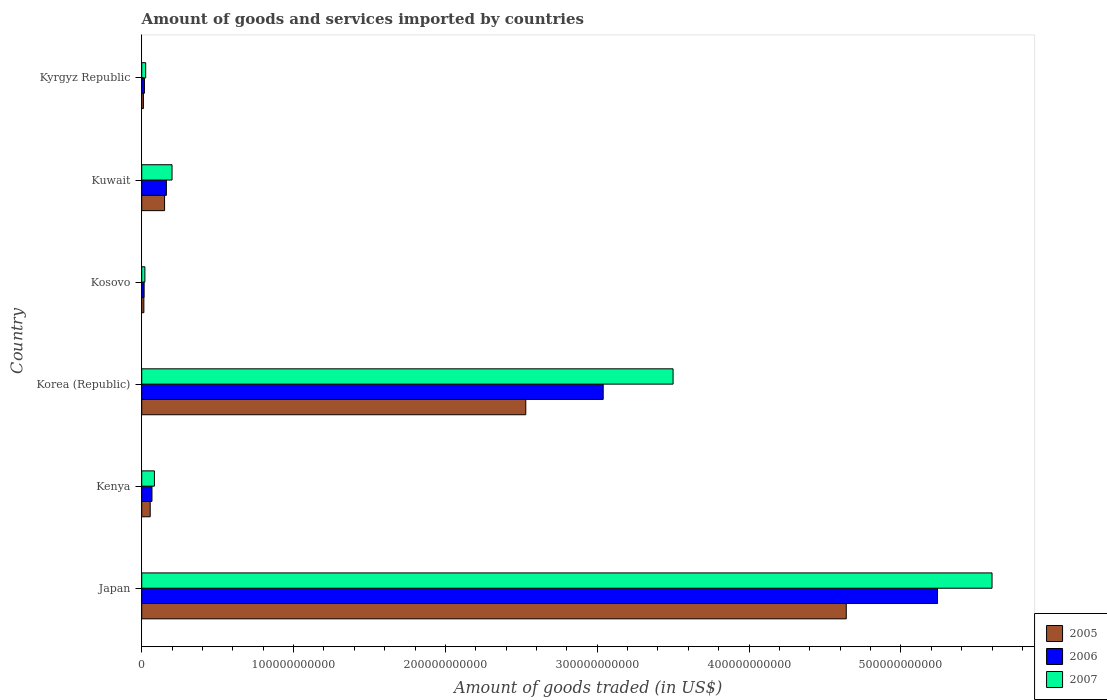How many groups of bars are there?
Your answer should be very brief. 6. Are the number of bars on each tick of the Y-axis equal?
Make the answer very short. Yes. How many bars are there on the 1st tick from the top?
Provide a succinct answer. 3. What is the label of the 5th group of bars from the top?
Give a very brief answer. Kenya. In how many cases, is the number of bars for a given country not equal to the number of legend labels?
Provide a short and direct response. 0. What is the total amount of goods and services imported in 2006 in Kosovo?
Provide a short and direct response. 1.58e+09. Across all countries, what is the maximum total amount of goods and services imported in 2005?
Provide a short and direct response. 4.64e+11. Across all countries, what is the minimum total amount of goods and services imported in 2005?
Provide a succinct answer. 1.11e+09. In which country was the total amount of goods and services imported in 2006 maximum?
Your answer should be compact. Japan. In which country was the total amount of goods and services imported in 2007 minimum?
Provide a short and direct response. Kosovo. What is the total total amount of goods and services imported in 2005 in the graph?
Keep it short and to the point. 7.40e+11. What is the difference between the total amount of goods and services imported in 2007 in Japan and that in Kuwait?
Offer a very short reply. 5.40e+11. What is the difference between the total amount of goods and services imported in 2007 in Japan and the total amount of goods and services imported in 2005 in Korea (Republic)?
Give a very brief answer. 3.07e+11. What is the average total amount of goods and services imported in 2007 per country?
Offer a very short reply. 1.57e+11. What is the difference between the total amount of goods and services imported in 2007 and total amount of goods and services imported in 2005 in Japan?
Provide a succinct answer. 9.60e+1. What is the ratio of the total amount of goods and services imported in 2006 in Japan to that in Kenya?
Offer a very short reply. 77.62. What is the difference between the highest and the second highest total amount of goods and services imported in 2005?
Ensure brevity in your answer.  2.11e+11. What is the difference between the highest and the lowest total amount of goods and services imported in 2005?
Provide a succinct answer. 4.63e+11. What does the 3rd bar from the top in Kosovo represents?
Offer a terse response. 2005. How many countries are there in the graph?
Your answer should be compact. 6. What is the difference between two consecutive major ticks on the X-axis?
Offer a very short reply. 1.00e+11. Are the values on the major ticks of X-axis written in scientific E-notation?
Offer a terse response. No. Does the graph contain any zero values?
Ensure brevity in your answer.  No. What is the title of the graph?
Ensure brevity in your answer.  Amount of goods and services imported by countries. Does "1990" appear as one of the legend labels in the graph?
Your answer should be compact. No. What is the label or title of the X-axis?
Make the answer very short. Amount of goods traded (in US$). What is the label or title of the Y-axis?
Ensure brevity in your answer.  Country. What is the Amount of goods traded (in US$) in 2005 in Japan?
Give a very brief answer. 4.64e+11. What is the Amount of goods traded (in US$) of 2006 in Japan?
Provide a succinct answer. 5.24e+11. What is the Amount of goods traded (in US$) in 2007 in Japan?
Offer a very short reply. 5.60e+11. What is the Amount of goods traded (in US$) in 2005 in Kenya?
Provide a short and direct response. 5.59e+09. What is the Amount of goods traded (in US$) of 2006 in Kenya?
Give a very brief answer. 6.75e+09. What is the Amount of goods traded (in US$) in 2007 in Kenya?
Provide a succinct answer. 8.37e+09. What is the Amount of goods traded (in US$) of 2005 in Korea (Republic)?
Offer a very short reply. 2.53e+11. What is the Amount of goods traded (in US$) of 2006 in Korea (Republic)?
Your response must be concise. 3.04e+11. What is the Amount of goods traded (in US$) of 2007 in Korea (Republic)?
Offer a very short reply. 3.50e+11. What is the Amount of goods traded (in US$) in 2005 in Kosovo?
Your answer should be compact. 1.42e+09. What is the Amount of goods traded (in US$) of 2006 in Kosovo?
Offer a very short reply. 1.58e+09. What is the Amount of goods traded (in US$) of 2007 in Kosovo?
Make the answer very short. 2.08e+09. What is the Amount of goods traded (in US$) of 2005 in Kuwait?
Provide a succinct answer. 1.51e+1. What is the Amount of goods traded (in US$) of 2006 in Kuwait?
Provide a succinct answer. 1.62e+1. What is the Amount of goods traded (in US$) of 2007 in Kuwait?
Your response must be concise. 2.00e+1. What is the Amount of goods traded (in US$) in 2005 in Kyrgyz Republic?
Provide a succinct answer. 1.11e+09. What is the Amount of goods traded (in US$) in 2006 in Kyrgyz Republic?
Your response must be concise. 1.79e+09. What is the Amount of goods traded (in US$) in 2007 in Kyrgyz Republic?
Keep it short and to the point. 2.61e+09. Across all countries, what is the maximum Amount of goods traded (in US$) in 2005?
Give a very brief answer. 4.64e+11. Across all countries, what is the maximum Amount of goods traded (in US$) in 2006?
Provide a succinct answer. 5.24e+11. Across all countries, what is the maximum Amount of goods traded (in US$) in 2007?
Provide a succinct answer. 5.60e+11. Across all countries, what is the minimum Amount of goods traded (in US$) of 2005?
Your response must be concise. 1.11e+09. Across all countries, what is the minimum Amount of goods traded (in US$) in 2006?
Offer a terse response. 1.58e+09. Across all countries, what is the minimum Amount of goods traded (in US$) in 2007?
Give a very brief answer. 2.08e+09. What is the total Amount of goods traded (in US$) in 2005 in the graph?
Offer a terse response. 7.40e+11. What is the total Amount of goods traded (in US$) in 2006 in the graph?
Make the answer very short. 8.54e+11. What is the total Amount of goods traded (in US$) of 2007 in the graph?
Your answer should be compact. 9.43e+11. What is the difference between the Amount of goods traded (in US$) in 2005 in Japan and that in Kenya?
Ensure brevity in your answer.  4.58e+11. What is the difference between the Amount of goods traded (in US$) of 2006 in Japan and that in Kenya?
Your answer should be very brief. 5.17e+11. What is the difference between the Amount of goods traded (in US$) in 2007 in Japan and that in Kenya?
Provide a succinct answer. 5.52e+11. What is the difference between the Amount of goods traded (in US$) in 2005 in Japan and that in Korea (Republic)?
Offer a terse response. 2.11e+11. What is the difference between the Amount of goods traded (in US$) in 2006 in Japan and that in Korea (Republic)?
Your answer should be very brief. 2.20e+11. What is the difference between the Amount of goods traded (in US$) in 2007 in Japan and that in Korea (Republic)?
Give a very brief answer. 2.10e+11. What is the difference between the Amount of goods traded (in US$) in 2005 in Japan and that in Kosovo?
Offer a terse response. 4.63e+11. What is the difference between the Amount of goods traded (in US$) in 2006 in Japan and that in Kosovo?
Give a very brief answer. 5.23e+11. What is the difference between the Amount of goods traded (in US$) in 2007 in Japan and that in Kosovo?
Offer a very short reply. 5.58e+11. What is the difference between the Amount of goods traded (in US$) of 2005 in Japan and that in Kuwait?
Your response must be concise. 4.49e+11. What is the difference between the Amount of goods traded (in US$) of 2006 in Japan and that in Kuwait?
Give a very brief answer. 5.08e+11. What is the difference between the Amount of goods traded (in US$) in 2007 in Japan and that in Kuwait?
Your response must be concise. 5.40e+11. What is the difference between the Amount of goods traded (in US$) in 2005 in Japan and that in Kyrgyz Republic?
Provide a succinct answer. 4.63e+11. What is the difference between the Amount of goods traded (in US$) of 2006 in Japan and that in Kyrgyz Republic?
Your response must be concise. 5.22e+11. What is the difference between the Amount of goods traded (in US$) in 2007 in Japan and that in Kyrgyz Republic?
Provide a succinct answer. 5.57e+11. What is the difference between the Amount of goods traded (in US$) of 2005 in Kenya and that in Korea (Republic)?
Provide a succinct answer. -2.47e+11. What is the difference between the Amount of goods traded (in US$) in 2006 in Kenya and that in Korea (Republic)?
Your answer should be compact. -2.97e+11. What is the difference between the Amount of goods traded (in US$) in 2007 in Kenya and that in Korea (Republic)?
Your answer should be very brief. -3.42e+11. What is the difference between the Amount of goods traded (in US$) in 2005 in Kenya and that in Kosovo?
Provide a succinct answer. 4.16e+09. What is the difference between the Amount of goods traded (in US$) of 2006 in Kenya and that in Kosovo?
Provide a succinct answer. 5.17e+09. What is the difference between the Amount of goods traded (in US$) in 2007 in Kenya and that in Kosovo?
Ensure brevity in your answer.  6.29e+09. What is the difference between the Amount of goods traded (in US$) of 2005 in Kenya and that in Kuwait?
Your answer should be very brief. -9.47e+09. What is the difference between the Amount of goods traded (in US$) of 2006 in Kenya and that in Kuwait?
Provide a short and direct response. -9.49e+09. What is the difference between the Amount of goods traded (in US$) of 2007 in Kenya and that in Kuwait?
Give a very brief answer. -1.16e+1. What is the difference between the Amount of goods traded (in US$) in 2005 in Kenya and that in Kyrgyz Republic?
Provide a succinct answer. 4.48e+09. What is the difference between the Amount of goods traded (in US$) in 2006 in Kenya and that in Kyrgyz Republic?
Offer a terse response. 4.96e+09. What is the difference between the Amount of goods traded (in US$) of 2007 in Kenya and that in Kyrgyz Republic?
Provide a short and direct response. 5.76e+09. What is the difference between the Amount of goods traded (in US$) of 2005 in Korea (Republic) and that in Kosovo?
Your response must be concise. 2.52e+11. What is the difference between the Amount of goods traded (in US$) of 2006 in Korea (Republic) and that in Kosovo?
Keep it short and to the point. 3.02e+11. What is the difference between the Amount of goods traded (in US$) of 2007 in Korea (Republic) and that in Kosovo?
Ensure brevity in your answer.  3.48e+11. What is the difference between the Amount of goods traded (in US$) in 2005 in Korea (Republic) and that in Kuwait?
Keep it short and to the point. 2.38e+11. What is the difference between the Amount of goods traded (in US$) in 2006 in Korea (Republic) and that in Kuwait?
Your answer should be very brief. 2.88e+11. What is the difference between the Amount of goods traded (in US$) of 2007 in Korea (Republic) and that in Kuwait?
Provide a short and direct response. 3.30e+11. What is the difference between the Amount of goods traded (in US$) of 2005 in Korea (Republic) and that in Kyrgyz Republic?
Your answer should be compact. 2.52e+11. What is the difference between the Amount of goods traded (in US$) of 2006 in Korea (Republic) and that in Kyrgyz Republic?
Your response must be concise. 3.02e+11. What is the difference between the Amount of goods traded (in US$) of 2007 in Korea (Republic) and that in Kyrgyz Republic?
Your answer should be very brief. 3.47e+11. What is the difference between the Amount of goods traded (in US$) in 2005 in Kosovo and that in Kuwait?
Offer a very short reply. -1.36e+1. What is the difference between the Amount of goods traded (in US$) of 2006 in Kosovo and that in Kuwait?
Make the answer very short. -1.47e+1. What is the difference between the Amount of goods traded (in US$) in 2007 in Kosovo and that in Kuwait?
Your response must be concise. -1.79e+1. What is the difference between the Amount of goods traded (in US$) of 2005 in Kosovo and that in Kyrgyz Republic?
Make the answer very short. 3.17e+08. What is the difference between the Amount of goods traded (in US$) of 2006 in Kosovo and that in Kyrgyz Republic?
Your response must be concise. -2.09e+08. What is the difference between the Amount of goods traded (in US$) in 2007 in Kosovo and that in Kyrgyz Republic?
Keep it short and to the point. -5.38e+08. What is the difference between the Amount of goods traded (in US$) in 2005 in Kuwait and that in Kyrgyz Republic?
Your answer should be very brief. 1.39e+1. What is the difference between the Amount of goods traded (in US$) of 2006 in Kuwait and that in Kyrgyz Republic?
Your response must be concise. 1.44e+1. What is the difference between the Amount of goods traded (in US$) in 2007 in Kuwait and that in Kyrgyz Republic?
Your answer should be very brief. 1.73e+1. What is the difference between the Amount of goods traded (in US$) in 2005 in Japan and the Amount of goods traded (in US$) in 2006 in Kenya?
Offer a terse response. 4.57e+11. What is the difference between the Amount of goods traded (in US$) of 2005 in Japan and the Amount of goods traded (in US$) of 2007 in Kenya?
Provide a succinct answer. 4.56e+11. What is the difference between the Amount of goods traded (in US$) of 2006 in Japan and the Amount of goods traded (in US$) of 2007 in Kenya?
Keep it short and to the point. 5.16e+11. What is the difference between the Amount of goods traded (in US$) in 2005 in Japan and the Amount of goods traded (in US$) in 2006 in Korea (Republic)?
Your answer should be very brief. 1.60e+11. What is the difference between the Amount of goods traded (in US$) of 2005 in Japan and the Amount of goods traded (in US$) of 2007 in Korea (Republic)?
Offer a very short reply. 1.14e+11. What is the difference between the Amount of goods traded (in US$) of 2006 in Japan and the Amount of goods traded (in US$) of 2007 in Korea (Republic)?
Offer a very short reply. 1.74e+11. What is the difference between the Amount of goods traded (in US$) in 2005 in Japan and the Amount of goods traded (in US$) in 2006 in Kosovo?
Your answer should be compact. 4.62e+11. What is the difference between the Amount of goods traded (in US$) in 2005 in Japan and the Amount of goods traded (in US$) in 2007 in Kosovo?
Your answer should be compact. 4.62e+11. What is the difference between the Amount of goods traded (in US$) in 2006 in Japan and the Amount of goods traded (in US$) in 2007 in Kosovo?
Your response must be concise. 5.22e+11. What is the difference between the Amount of goods traded (in US$) of 2005 in Japan and the Amount of goods traded (in US$) of 2006 in Kuwait?
Keep it short and to the point. 4.48e+11. What is the difference between the Amount of goods traded (in US$) in 2005 in Japan and the Amount of goods traded (in US$) in 2007 in Kuwait?
Offer a terse response. 4.44e+11. What is the difference between the Amount of goods traded (in US$) in 2006 in Japan and the Amount of goods traded (in US$) in 2007 in Kuwait?
Provide a succinct answer. 5.04e+11. What is the difference between the Amount of goods traded (in US$) in 2005 in Japan and the Amount of goods traded (in US$) in 2006 in Kyrgyz Republic?
Ensure brevity in your answer.  4.62e+11. What is the difference between the Amount of goods traded (in US$) in 2005 in Japan and the Amount of goods traded (in US$) in 2007 in Kyrgyz Republic?
Keep it short and to the point. 4.61e+11. What is the difference between the Amount of goods traded (in US$) of 2006 in Japan and the Amount of goods traded (in US$) of 2007 in Kyrgyz Republic?
Your answer should be compact. 5.21e+11. What is the difference between the Amount of goods traded (in US$) of 2005 in Kenya and the Amount of goods traded (in US$) of 2006 in Korea (Republic)?
Provide a short and direct response. -2.98e+11. What is the difference between the Amount of goods traded (in US$) of 2005 in Kenya and the Amount of goods traded (in US$) of 2007 in Korea (Republic)?
Give a very brief answer. -3.44e+11. What is the difference between the Amount of goods traded (in US$) in 2006 in Kenya and the Amount of goods traded (in US$) in 2007 in Korea (Republic)?
Give a very brief answer. -3.43e+11. What is the difference between the Amount of goods traded (in US$) in 2005 in Kenya and the Amount of goods traded (in US$) in 2006 in Kosovo?
Your answer should be very brief. 4.00e+09. What is the difference between the Amount of goods traded (in US$) of 2005 in Kenya and the Amount of goods traded (in US$) of 2007 in Kosovo?
Make the answer very short. 3.51e+09. What is the difference between the Amount of goods traded (in US$) in 2006 in Kenya and the Amount of goods traded (in US$) in 2007 in Kosovo?
Your answer should be compact. 4.68e+09. What is the difference between the Amount of goods traded (in US$) in 2005 in Kenya and the Amount of goods traded (in US$) in 2006 in Kuwait?
Your answer should be compact. -1.07e+1. What is the difference between the Amount of goods traded (in US$) of 2005 in Kenya and the Amount of goods traded (in US$) of 2007 in Kuwait?
Make the answer very short. -1.44e+1. What is the difference between the Amount of goods traded (in US$) of 2006 in Kenya and the Amount of goods traded (in US$) of 2007 in Kuwait?
Provide a succinct answer. -1.32e+1. What is the difference between the Amount of goods traded (in US$) of 2005 in Kenya and the Amount of goods traded (in US$) of 2006 in Kyrgyz Republic?
Your answer should be very brief. 3.79e+09. What is the difference between the Amount of goods traded (in US$) in 2005 in Kenya and the Amount of goods traded (in US$) in 2007 in Kyrgyz Republic?
Your answer should be compact. 2.97e+09. What is the difference between the Amount of goods traded (in US$) in 2006 in Kenya and the Amount of goods traded (in US$) in 2007 in Kyrgyz Republic?
Provide a succinct answer. 4.14e+09. What is the difference between the Amount of goods traded (in US$) in 2005 in Korea (Republic) and the Amount of goods traded (in US$) in 2006 in Kosovo?
Ensure brevity in your answer.  2.51e+11. What is the difference between the Amount of goods traded (in US$) of 2005 in Korea (Republic) and the Amount of goods traded (in US$) of 2007 in Kosovo?
Keep it short and to the point. 2.51e+11. What is the difference between the Amount of goods traded (in US$) in 2006 in Korea (Republic) and the Amount of goods traded (in US$) in 2007 in Kosovo?
Keep it short and to the point. 3.02e+11. What is the difference between the Amount of goods traded (in US$) in 2005 in Korea (Republic) and the Amount of goods traded (in US$) in 2006 in Kuwait?
Ensure brevity in your answer.  2.37e+11. What is the difference between the Amount of goods traded (in US$) of 2005 in Korea (Republic) and the Amount of goods traded (in US$) of 2007 in Kuwait?
Ensure brevity in your answer.  2.33e+11. What is the difference between the Amount of goods traded (in US$) in 2006 in Korea (Republic) and the Amount of goods traded (in US$) in 2007 in Kuwait?
Make the answer very short. 2.84e+11. What is the difference between the Amount of goods traded (in US$) of 2005 in Korea (Republic) and the Amount of goods traded (in US$) of 2006 in Kyrgyz Republic?
Give a very brief answer. 2.51e+11. What is the difference between the Amount of goods traded (in US$) in 2005 in Korea (Republic) and the Amount of goods traded (in US$) in 2007 in Kyrgyz Republic?
Your answer should be compact. 2.50e+11. What is the difference between the Amount of goods traded (in US$) of 2006 in Korea (Republic) and the Amount of goods traded (in US$) of 2007 in Kyrgyz Republic?
Provide a short and direct response. 3.01e+11. What is the difference between the Amount of goods traded (in US$) in 2005 in Kosovo and the Amount of goods traded (in US$) in 2006 in Kuwait?
Provide a succinct answer. -1.48e+1. What is the difference between the Amount of goods traded (in US$) in 2005 in Kosovo and the Amount of goods traded (in US$) in 2007 in Kuwait?
Make the answer very short. -1.85e+1. What is the difference between the Amount of goods traded (in US$) of 2006 in Kosovo and the Amount of goods traded (in US$) of 2007 in Kuwait?
Keep it short and to the point. -1.84e+1. What is the difference between the Amount of goods traded (in US$) of 2005 in Kosovo and the Amount of goods traded (in US$) of 2006 in Kyrgyz Republic?
Ensure brevity in your answer.  -3.70e+08. What is the difference between the Amount of goods traded (in US$) in 2005 in Kosovo and the Amount of goods traded (in US$) in 2007 in Kyrgyz Republic?
Your response must be concise. -1.19e+09. What is the difference between the Amount of goods traded (in US$) in 2006 in Kosovo and the Amount of goods traded (in US$) in 2007 in Kyrgyz Republic?
Keep it short and to the point. -1.03e+09. What is the difference between the Amount of goods traded (in US$) of 2005 in Kuwait and the Amount of goods traded (in US$) of 2006 in Kyrgyz Republic?
Ensure brevity in your answer.  1.33e+1. What is the difference between the Amount of goods traded (in US$) in 2005 in Kuwait and the Amount of goods traded (in US$) in 2007 in Kyrgyz Republic?
Your response must be concise. 1.24e+1. What is the difference between the Amount of goods traded (in US$) of 2006 in Kuwait and the Amount of goods traded (in US$) of 2007 in Kyrgyz Republic?
Offer a very short reply. 1.36e+1. What is the average Amount of goods traded (in US$) of 2005 per country?
Keep it short and to the point. 1.23e+11. What is the average Amount of goods traded (in US$) in 2006 per country?
Your answer should be very brief. 1.42e+11. What is the average Amount of goods traded (in US$) of 2007 per country?
Ensure brevity in your answer.  1.57e+11. What is the difference between the Amount of goods traded (in US$) in 2005 and Amount of goods traded (in US$) in 2006 in Japan?
Offer a very short reply. -6.01e+1. What is the difference between the Amount of goods traded (in US$) of 2005 and Amount of goods traded (in US$) of 2007 in Japan?
Your answer should be very brief. -9.60e+1. What is the difference between the Amount of goods traded (in US$) in 2006 and Amount of goods traded (in US$) in 2007 in Japan?
Your answer should be very brief. -3.59e+1. What is the difference between the Amount of goods traded (in US$) in 2005 and Amount of goods traded (in US$) in 2006 in Kenya?
Make the answer very short. -1.17e+09. What is the difference between the Amount of goods traded (in US$) of 2005 and Amount of goods traded (in US$) of 2007 in Kenya?
Provide a succinct answer. -2.78e+09. What is the difference between the Amount of goods traded (in US$) of 2006 and Amount of goods traded (in US$) of 2007 in Kenya?
Provide a short and direct response. -1.62e+09. What is the difference between the Amount of goods traded (in US$) in 2005 and Amount of goods traded (in US$) in 2006 in Korea (Republic)?
Your answer should be compact. -5.10e+1. What is the difference between the Amount of goods traded (in US$) of 2005 and Amount of goods traded (in US$) of 2007 in Korea (Republic)?
Ensure brevity in your answer.  -9.70e+1. What is the difference between the Amount of goods traded (in US$) of 2006 and Amount of goods traded (in US$) of 2007 in Korea (Republic)?
Your response must be concise. -4.60e+1. What is the difference between the Amount of goods traded (in US$) in 2005 and Amount of goods traded (in US$) in 2006 in Kosovo?
Give a very brief answer. -1.61e+08. What is the difference between the Amount of goods traded (in US$) of 2005 and Amount of goods traded (in US$) of 2007 in Kosovo?
Keep it short and to the point. -6.53e+08. What is the difference between the Amount of goods traded (in US$) of 2006 and Amount of goods traded (in US$) of 2007 in Kosovo?
Provide a succinct answer. -4.92e+08. What is the difference between the Amount of goods traded (in US$) of 2005 and Amount of goods traded (in US$) of 2006 in Kuwait?
Your answer should be compact. -1.19e+09. What is the difference between the Amount of goods traded (in US$) of 2005 and Amount of goods traded (in US$) of 2007 in Kuwait?
Keep it short and to the point. -4.91e+09. What is the difference between the Amount of goods traded (in US$) of 2006 and Amount of goods traded (in US$) of 2007 in Kuwait?
Keep it short and to the point. -3.72e+09. What is the difference between the Amount of goods traded (in US$) of 2005 and Amount of goods traded (in US$) of 2006 in Kyrgyz Republic?
Provide a succinct answer. -6.87e+08. What is the difference between the Amount of goods traded (in US$) in 2005 and Amount of goods traded (in US$) in 2007 in Kyrgyz Republic?
Provide a short and direct response. -1.51e+09. What is the difference between the Amount of goods traded (in US$) in 2006 and Amount of goods traded (in US$) in 2007 in Kyrgyz Republic?
Keep it short and to the point. -8.21e+08. What is the ratio of the Amount of goods traded (in US$) of 2005 in Japan to that in Kenya?
Make the answer very short. 83.06. What is the ratio of the Amount of goods traded (in US$) in 2006 in Japan to that in Kenya?
Provide a short and direct response. 77.62. What is the ratio of the Amount of goods traded (in US$) in 2007 in Japan to that in Kenya?
Offer a terse response. 66.92. What is the ratio of the Amount of goods traded (in US$) in 2005 in Japan to that in Korea (Republic)?
Provide a succinct answer. 1.83. What is the ratio of the Amount of goods traded (in US$) in 2006 in Japan to that in Korea (Republic)?
Offer a very short reply. 1.72. What is the ratio of the Amount of goods traded (in US$) in 2007 in Japan to that in Korea (Republic)?
Provide a succinct answer. 1.6. What is the ratio of the Amount of goods traded (in US$) in 2005 in Japan to that in Kosovo?
Offer a very short reply. 326.15. What is the ratio of the Amount of goods traded (in US$) in 2006 in Japan to that in Kosovo?
Ensure brevity in your answer.  330.99. What is the ratio of the Amount of goods traded (in US$) in 2007 in Japan to that in Kosovo?
Make the answer very short. 269.84. What is the ratio of the Amount of goods traded (in US$) in 2005 in Japan to that in Kuwait?
Provide a short and direct response. 30.82. What is the ratio of the Amount of goods traded (in US$) in 2006 in Japan to that in Kuwait?
Keep it short and to the point. 32.27. What is the ratio of the Amount of goods traded (in US$) in 2007 in Japan to that in Kuwait?
Offer a very short reply. 28.05. What is the ratio of the Amount of goods traded (in US$) in 2005 in Japan to that in Kyrgyz Republic?
Offer a very short reply. 419.72. What is the ratio of the Amount of goods traded (in US$) of 2006 in Japan to that in Kyrgyz Republic?
Provide a succinct answer. 292.4. What is the ratio of the Amount of goods traded (in US$) in 2007 in Japan to that in Kyrgyz Republic?
Your answer should be compact. 214.27. What is the ratio of the Amount of goods traded (in US$) of 2005 in Kenya to that in Korea (Republic)?
Keep it short and to the point. 0.02. What is the ratio of the Amount of goods traded (in US$) of 2006 in Kenya to that in Korea (Republic)?
Your answer should be very brief. 0.02. What is the ratio of the Amount of goods traded (in US$) of 2007 in Kenya to that in Korea (Republic)?
Provide a short and direct response. 0.02. What is the ratio of the Amount of goods traded (in US$) of 2005 in Kenya to that in Kosovo?
Provide a short and direct response. 3.93. What is the ratio of the Amount of goods traded (in US$) of 2006 in Kenya to that in Kosovo?
Give a very brief answer. 4.26. What is the ratio of the Amount of goods traded (in US$) in 2007 in Kenya to that in Kosovo?
Provide a short and direct response. 4.03. What is the ratio of the Amount of goods traded (in US$) in 2005 in Kenya to that in Kuwait?
Keep it short and to the point. 0.37. What is the ratio of the Amount of goods traded (in US$) in 2006 in Kenya to that in Kuwait?
Offer a terse response. 0.42. What is the ratio of the Amount of goods traded (in US$) in 2007 in Kenya to that in Kuwait?
Provide a succinct answer. 0.42. What is the ratio of the Amount of goods traded (in US$) of 2005 in Kenya to that in Kyrgyz Republic?
Provide a short and direct response. 5.05. What is the ratio of the Amount of goods traded (in US$) in 2006 in Kenya to that in Kyrgyz Republic?
Ensure brevity in your answer.  3.77. What is the ratio of the Amount of goods traded (in US$) in 2007 in Kenya to that in Kyrgyz Republic?
Provide a short and direct response. 3.2. What is the ratio of the Amount of goods traded (in US$) of 2005 in Korea (Republic) to that in Kosovo?
Your answer should be compact. 177.79. What is the ratio of the Amount of goods traded (in US$) of 2006 in Korea (Republic) to that in Kosovo?
Offer a very short reply. 191.94. What is the ratio of the Amount of goods traded (in US$) in 2007 in Korea (Republic) to that in Kosovo?
Give a very brief answer. 168.62. What is the ratio of the Amount of goods traded (in US$) in 2005 in Korea (Republic) to that in Kuwait?
Offer a terse response. 16.8. What is the ratio of the Amount of goods traded (in US$) in 2006 in Korea (Republic) to that in Kuwait?
Give a very brief answer. 18.71. What is the ratio of the Amount of goods traded (in US$) in 2007 in Korea (Republic) to that in Kuwait?
Offer a very short reply. 17.53. What is the ratio of the Amount of goods traded (in US$) of 2005 in Korea (Republic) to that in Kyrgyz Republic?
Make the answer very short. 228.79. What is the ratio of the Amount of goods traded (in US$) in 2006 in Korea (Republic) to that in Kyrgyz Republic?
Offer a terse response. 169.56. What is the ratio of the Amount of goods traded (in US$) of 2007 in Korea (Republic) to that in Kyrgyz Republic?
Provide a short and direct response. 133.9. What is the ratio of the Amount of goods traded (in US$) of 2005 in Kosovo to that in Kuwait?
Offer a terse response. 0.09. What is the ratio of the Amount of goods traded (in US$) of 2006 in Kosovo to that in Kuwait?
Provide a succinct answer. 0.1. What is the ratio of the Amount of goods traded (in US$) in 2007 in Kosovo to that in Kuwait?
Provide a succinct answer. 0.1. What is the ratio of the Amount of goods traded (in US$) in 2005 in Kosovo to that in Kyrgyz Republic?
Provide a succinct answer. 1.29. What is the ratio of the Amount of goods traded (in US$) of 2006 in Kosovo to that in Kyrgyz Republic?
Your answer should be compact. 0.88. What is the ratio of the Amount of goods traded (in US$) in 2007 in Kosovo to that in Kyrgyz Republic?
Make the answer very short. 0.79. What is the ratio of the Amount of goods traded (in US$) in 2005 in Kuwait to that in Kyrgyz Republic?
Provide a short and direct response. 13.62. What is the ratio of the Amount of goods traded (in US$) in 2006 in Kuwait to that in Kyrgyz Republic?
Provide a short and direct response. 9.06. What is the ratio of the Amount of goods traded (in US$) of 2007 in Kuwait to that in Kyrgyz Republic?
Keep it short and to the point. 7.64. What is the difference between the highest and the second highest Amount of goods traded (in US$) of 2005?
Ensure brevity in your answer.  2.11e+11. What is the difference between the highest and the second highest Amount of goods traded (in US$) in 2006?
Your answer should be very brief. 2.20e+11. What is the difference between the highest and the second highest Amount of goods traded (in US$) of 2007?
Keep it short and to the point. 2.10e+11. What is the difference between the highest and the lowest Amount of goods traded (in US$) of 2005?
Give a very brief answer. 4.63e+11. What is the difference between the highest and the lowest Amount of goods traded (in US$) of 2006?
Your answer should be very brief. 5.23e+11. What is the difference between the highest and the lowest Amount of goods traded (in US$) of 2007?
Ensure brevity in your answer.  5.58e+11. 